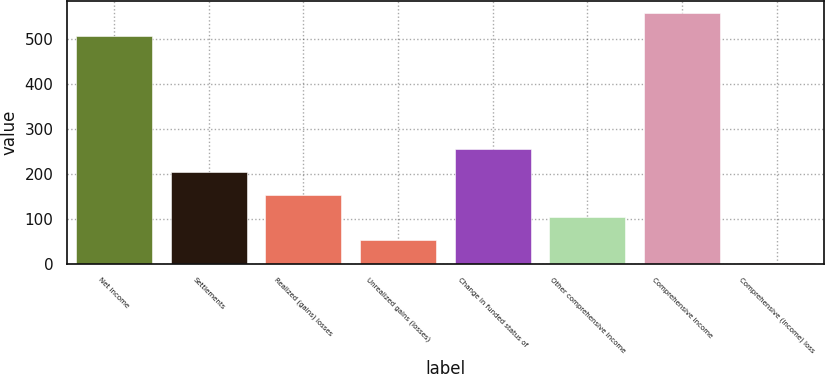Convert chart to OTSL. <chart><loc_0><loc_0><loc_500><loc_500><bar_chart><fcel>Net income<fcel>Settlements<fcel>Realized (gains) losses<fcel>Unrealized gains (losses)<fcel>Change in funded status of<fcel>Other comprehensive income<fcel>Comprehensive income<fcel>Comprehensive (income) loss<nl><fcel>507.5<fcel>204.76<fcel>153.82<fcel>51.94<fcel>255.7<fcel>102.88<fcel>558.44<fcel>1<nl></chart> 